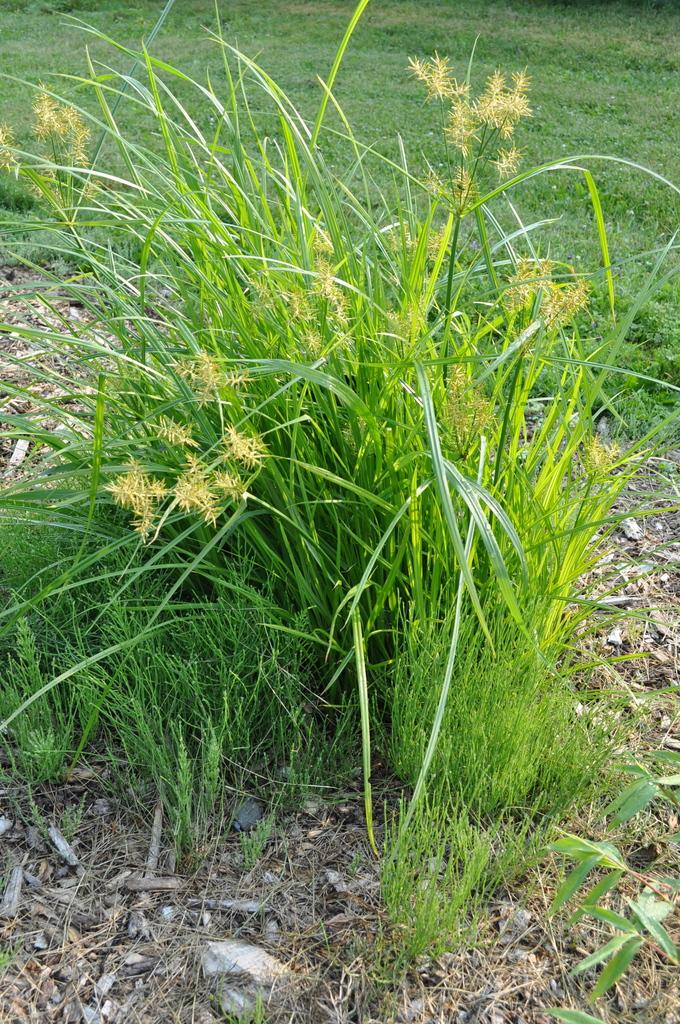What type of vegetation is present in the image? There is grass in the image. What other objects can be seen in the image? There are stones and wooden sticks in the image. What type of fabric is draped over the wooden sticks in the image? There is no fabric present in the image; it only features grass, stones, and wooden sticks. 